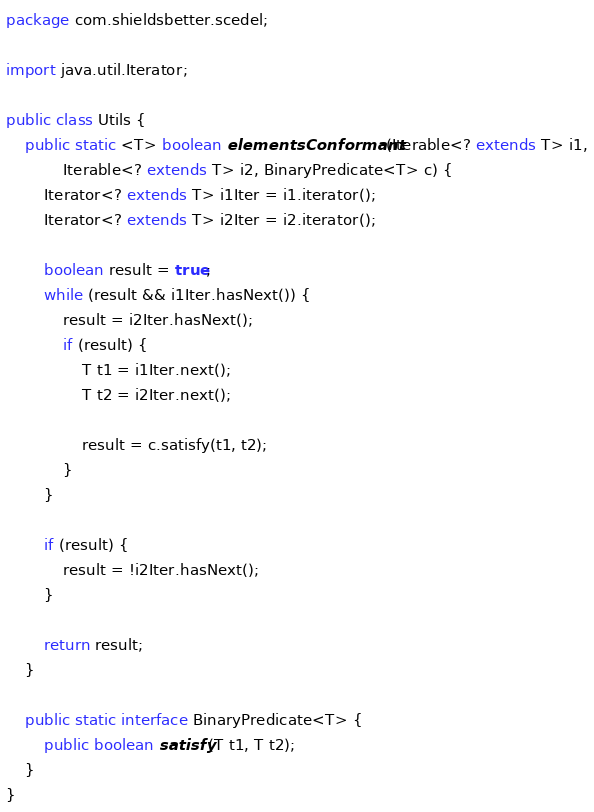<code> <loc_0><loc_0><loc_500><loc_500><_Java_>package com.shieldsbetter.scedel;

import java.util.Iterator;

public class Utils {
    public static <T> boolean elementsConformant(Iterable<? extends T> i1,
            Iterable<? extends T> i2, BinaryPredicate<T> c) {
        Iterator<? extends T> i1Iter = i1.iterator();
        Iterator<? extends T> i2Iter = i2.iterator();
        
        boolean result = true;
        while (result && i1Iter.hasNext()) {
            result = i2Iter.hasNext();
            if (result) {
                T t1 = i1Iter.next();
                T t2 = i2Iter.next();
                
                result = c.satisfy(t1, t2);
            }
        }
        
        if (result) {
            result = !i2Iter.hasNext();
        }
        
        return result;
    }
    
    public static interface BinaryPredicate<T> {
        public boolean satisfy(T t1, T t2);
    }
}
</code> 